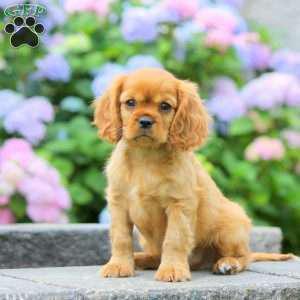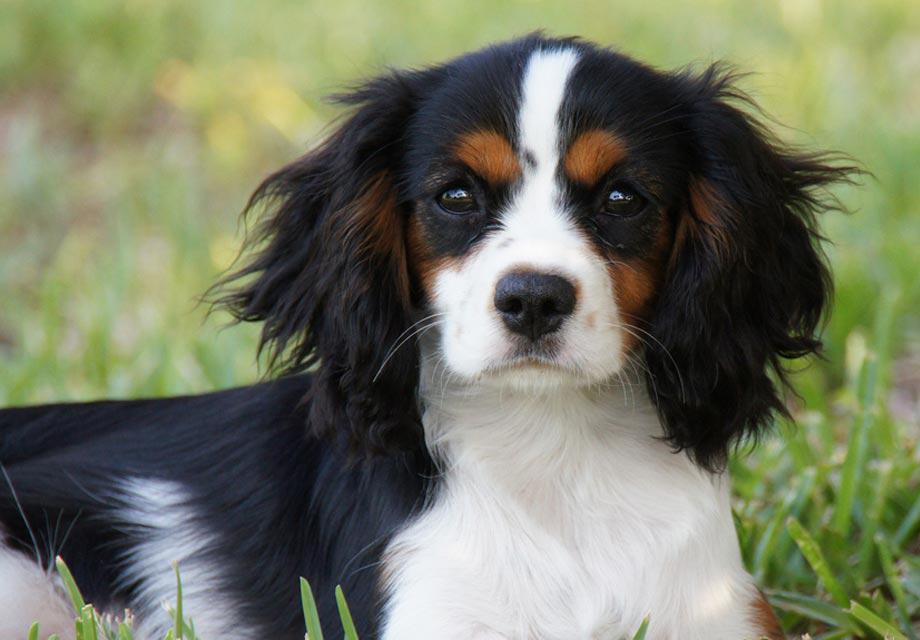The first image is the image on the left, the second image is the image on the right. Examine the images to the left and right. Is the description "Pinkish flowers are in the background behind at least one dog that is sitting upright." accurate? Answer yes or no. Yes. The first image is the image on the left, the second image is the image on the right. Assess this claim about the two images: "There is exactly one dog with black and white fur.". Correct or not? Answer yes or no. Yes. 